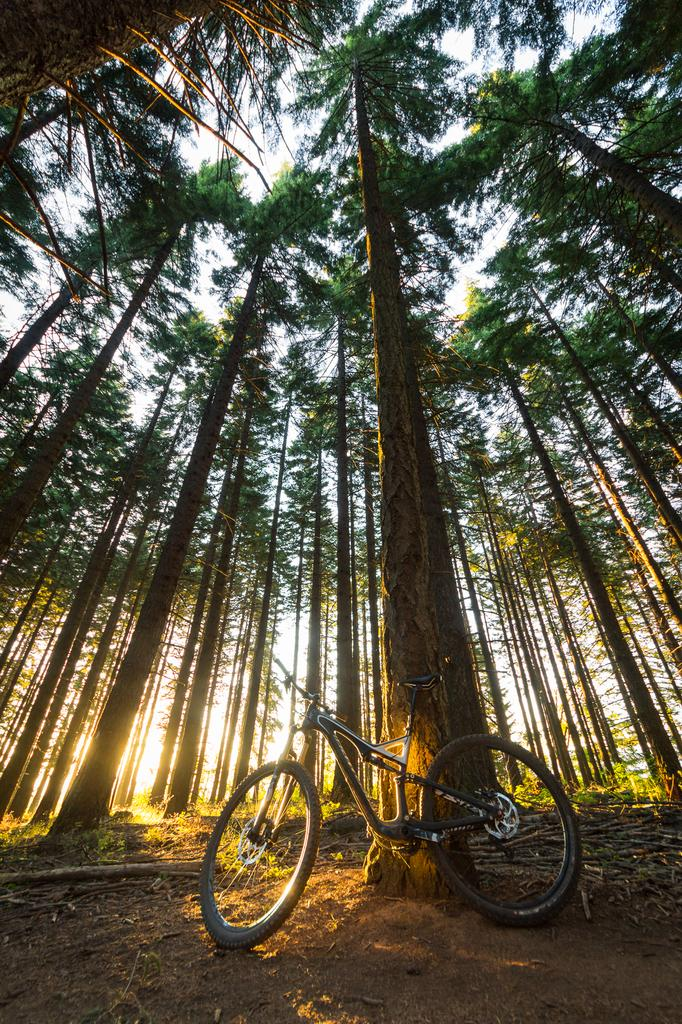What is the main object in the image? There is a bicycle in the image. Where is the bicycle located? The bicycle is on the land. What type of natural elements can be seen in the image? There are trees in the image. What is visible in the background of the image? The sky is visible in the background of the image. What letters can be seen on the bicycle in the image? There are no letters visible on the bicycle in the image. How many eggs are present on the bicycle in the image? There are no eggs present on the bicycle in the image. 